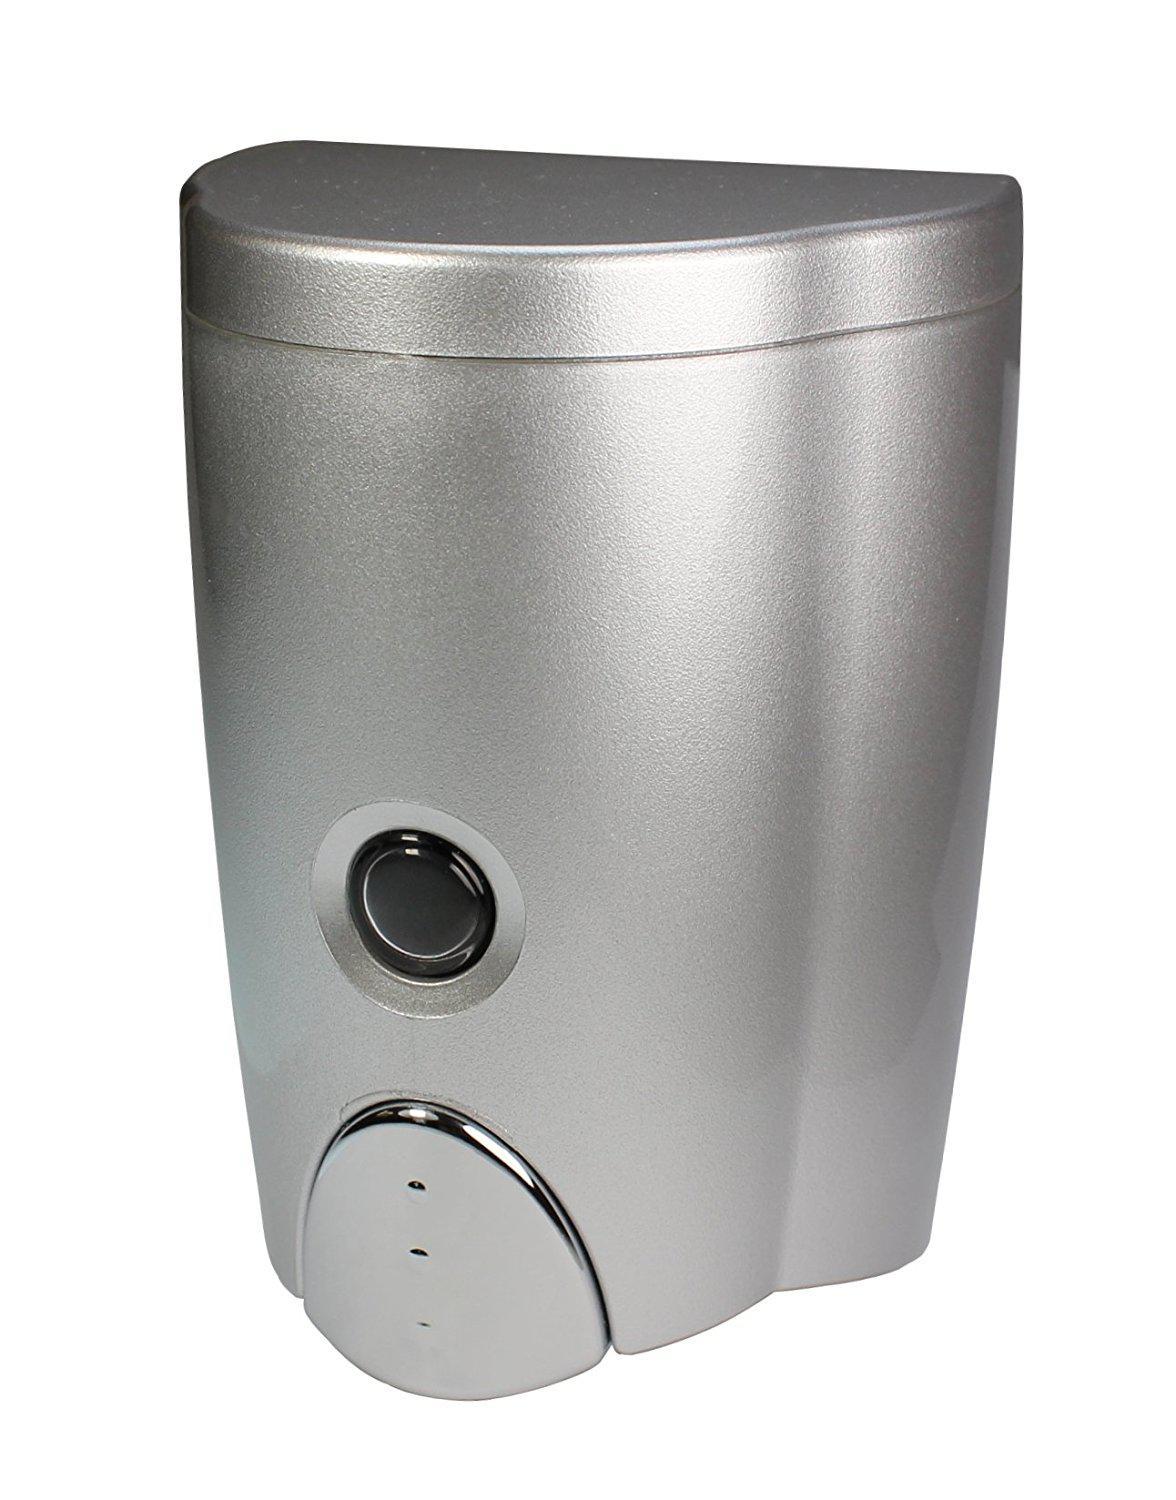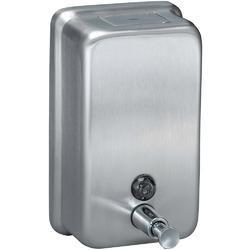The first image is the image on the left, the second image is the image on the right. For the images shown, is this caption "One dispenser is cylinder shaped with a pump at the top." true? Answer yes or no. No. 